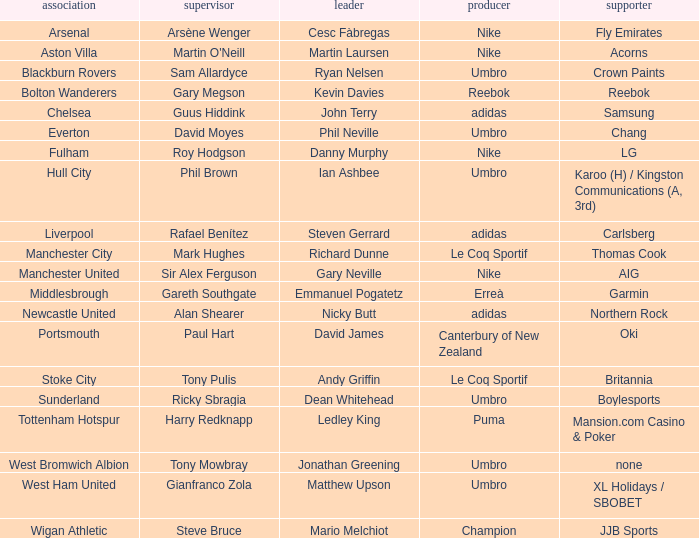Who is Dean Whitehead's manager? Ricky Sbragia. 